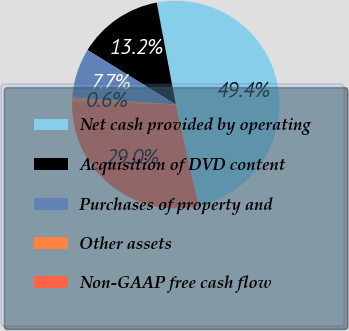<chart> <loc_0><loc_0><loc_500><loc_500><pie_chart><fcel>Net cash provided by operating<fcel>Acquisition of DVD content<fcel>Purchases of property and<fcel>Other assets<fcel>Non-GAAP free cash flow<nl><fcel>49.43%<fcel>13.25%<fcel>7.73%<fcel>0.57%<fcel>29.02%<nl></chart> 